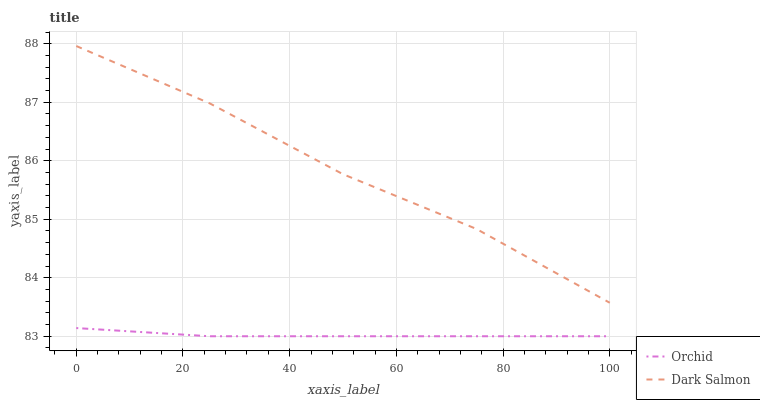Does Orchid have the maximum area under the curve?
Answer yes or no. No. Is Orchid the roughest?
Answer yes or no. No. Does Orchid have the highest value?
Answer yes or no. No. Is Orchid less than Dark Salmon?
Answer yes or no. Yes. Is Dark Salmon greater than Orchid?
Answer yes or no. Yes. Does Orchid intersect Dark Salmon?
Answer yes or no. No. 